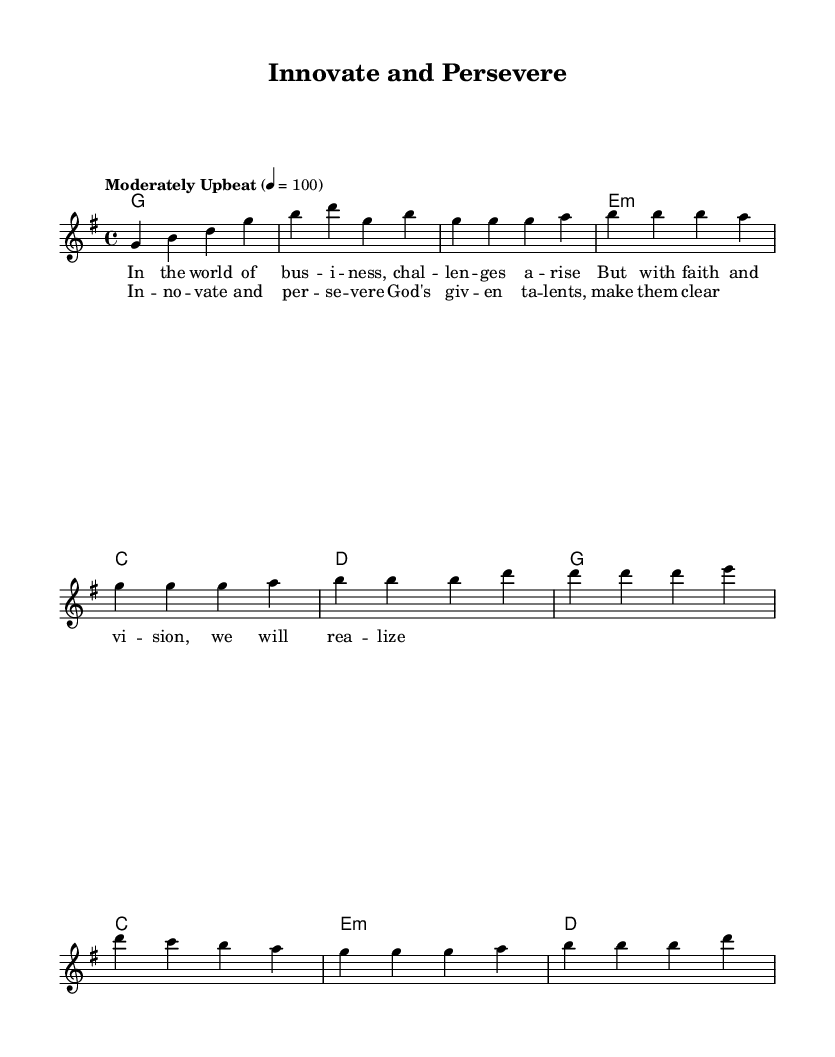What is the key signature of this music? The key signature is G major, which has one sharp (F#). It can be identified by looking at the beginning of the score, where the key signature is notated.
Answer: G major What is the time signature of this piece? The time signature is 4/4, indicated at the beginning of the score. This means there are four beats in each measure and a quarter note receives one beat.
Answer: 4/4 What is the tempo marking of this piece? The tempo is marked as "Moderately Upbeat" with a metronome setting of 100 beats per minute. This can be found in the tempo directive at the start of the score.
Answer: Moderately Upbeat How many measures are in the verse section? The verse section contains 4 measures, which can be counted by looking at the notation where the verse lyrics are set to the melody. Each line of lyrics corresponds to a measure.
Answer: 4 What are the chords used in the chorus? The chords in the chorus are G, C, E minor, and D. These are written in the chord symbols above the staff that accompanies the melody.
Answer: G, C, E minor, D What is the main theme expressed in the lyrics? The main theme is about faith and perseverance in business challenges. This can be discerned from the lyrics presented in the verse, which highlight overcoming difficulties through faith and vision.
Answer: Faith and perseverance What is the structure of this piece? The structure consists of an intro, a verse, and a chorus. This can be determined by looking at how the measures are organized along with the sections labeled in the score layout.
Answer: Intro, verse, chorus 